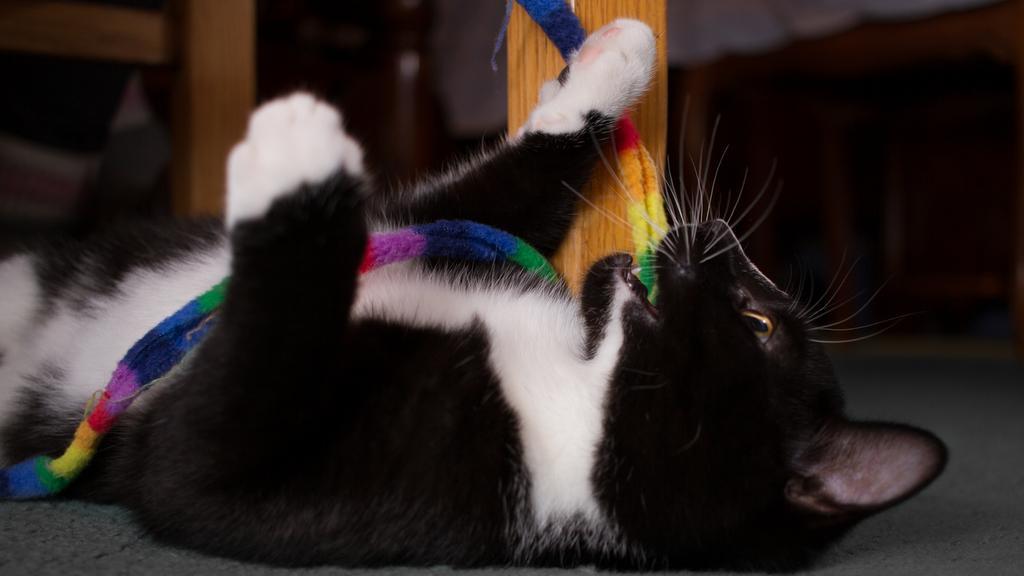In one or two sentences, can you explain what this image depicts? In this picture we can see a cat on the ground, here we can see wooden objects and some objects. 